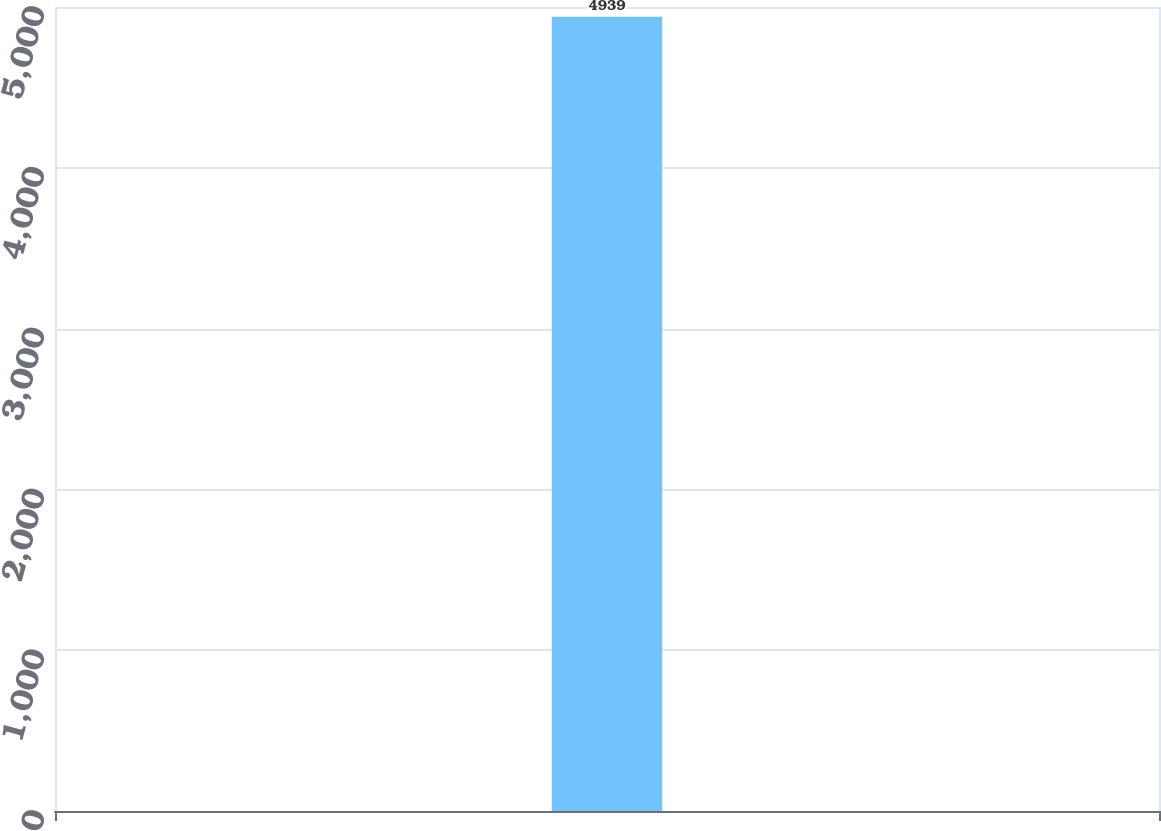Convert chart. <chart><loc_0><loc_0><loc_500><loc_500><bar_chart><ecel><nl><fcel>4939<nl></chart> 